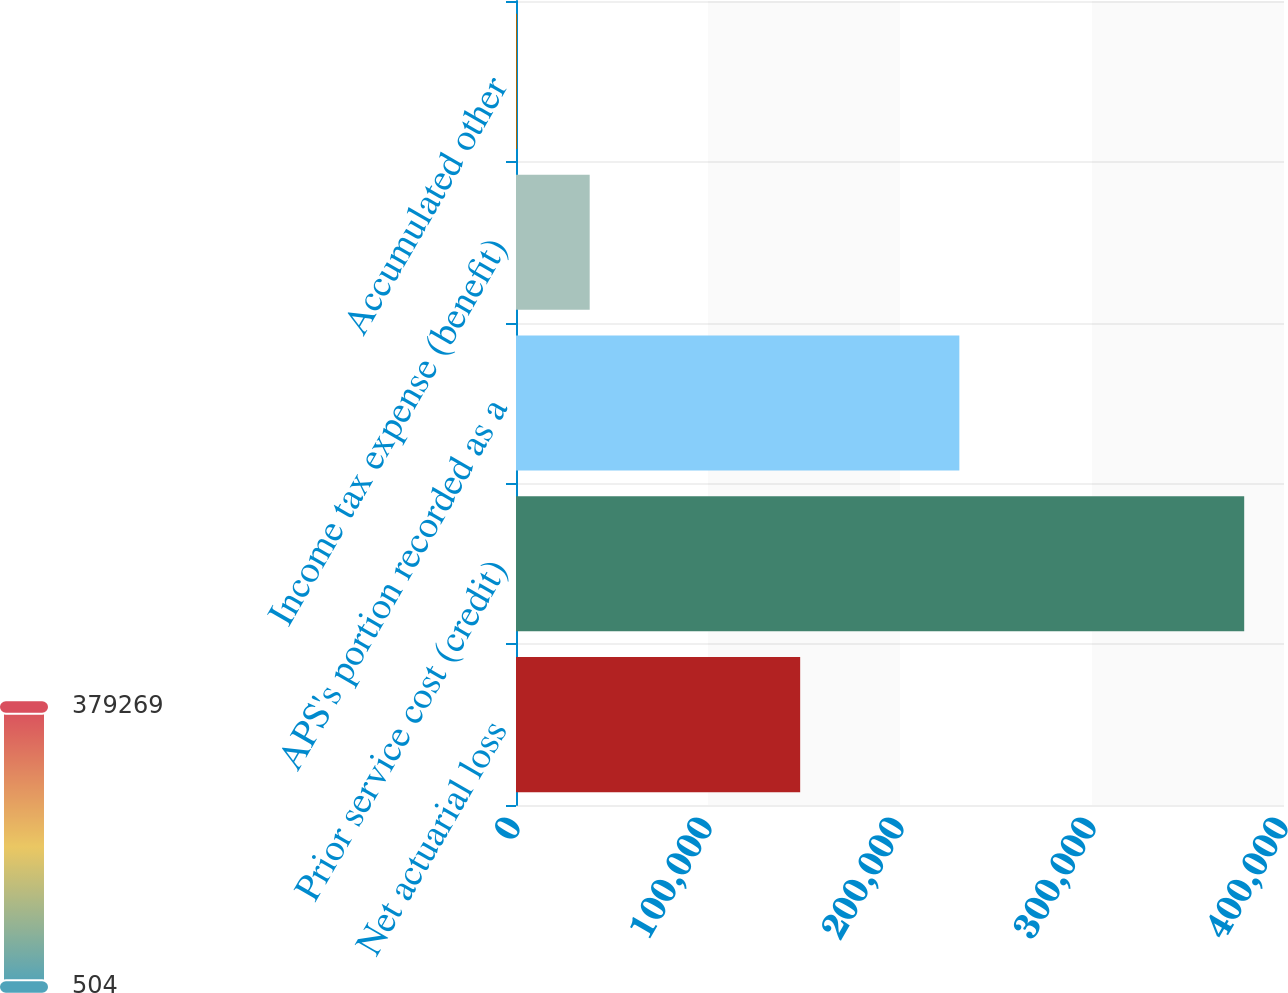<chart> <loc_0><loc_0><loc_500><loc_500><bar_chart><fcel>Net actuarial loss<fcel>Prior service cost (credit)<fcel>APS's portion recorded as a<fcel>Income tax expense (benefit)<fcel>Accumulated other<nl><fcel>148006<fcel>379269<fcel>230916<fcel>38380.5<fcel>504<nl></chart> 